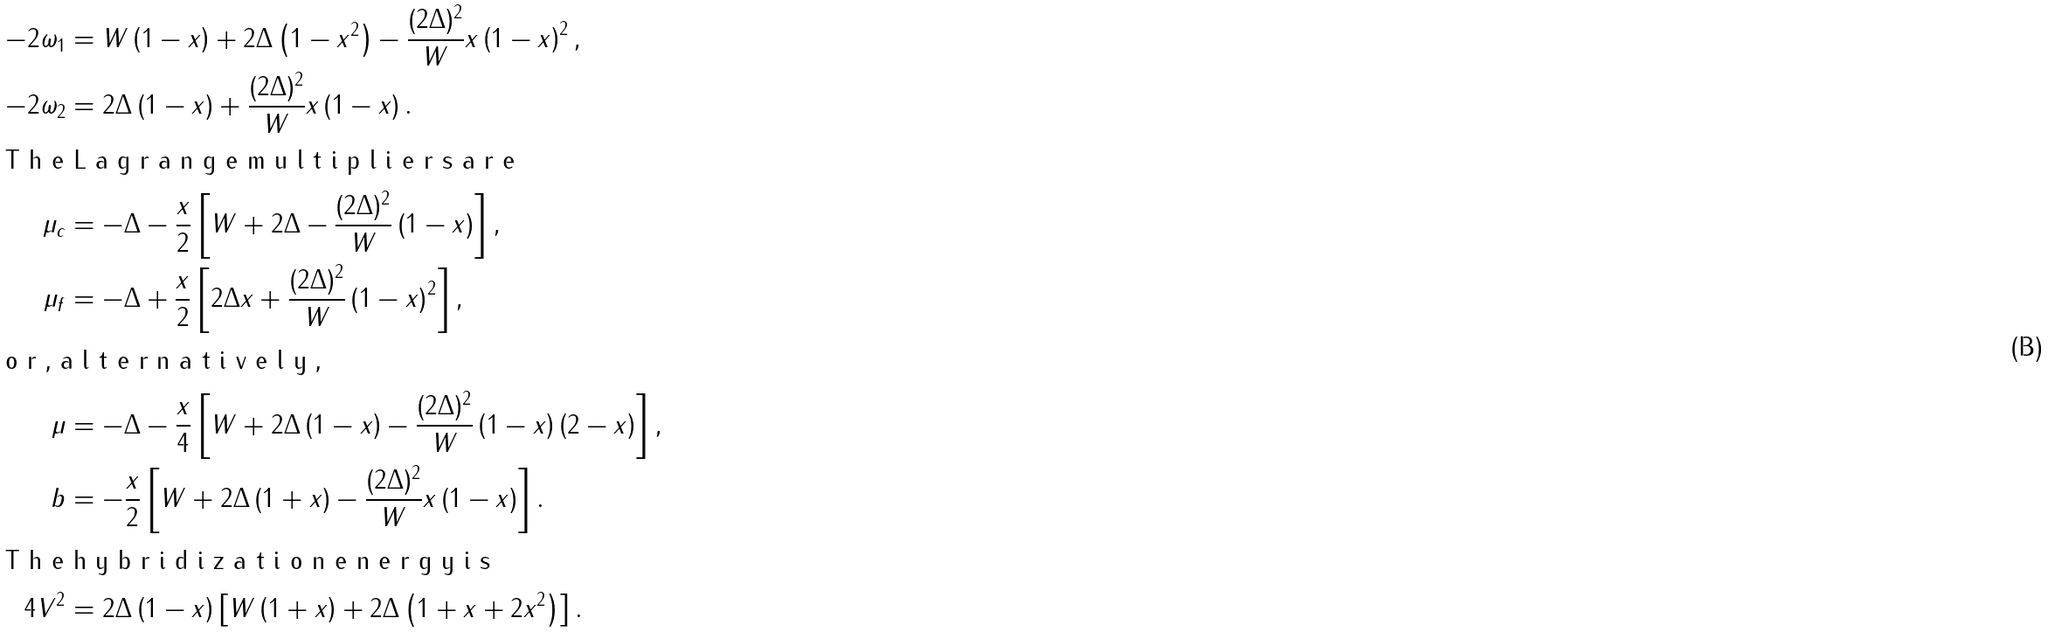<formula> <loc_0><loc_0><loc_500><loc_500>- 2 \omega _ { 1 } & = W \left ( 1 - x \right ) + 2 \Delta \left ( 1 - x ^ { 2 } \right ) - \frac { ( 2 \Delta ) ^ { 2 } } { W } x \left ( 1 - x \right ) ^ { 2 } , \\ - 2 \omega _ { 2 } & = 2 \Delta \left ( 1 - x \right ) + \frac { ( 2 \Delta ) ^ { 2 } } { W } x \left ( 1 - x \right ) . \intertext { T h e L a g r a n g e m u l t i p l i e r s a r e } \mu _ { c } & = - \Delta - \frac { x } { 2 } \left [ W + 2 \Delta - \frac { ( 2 \Delta ) ^ { 2 } } { W } \left ( 1 - x \right ) \right ] , \\ \mu _ { f } & = - \Delta + \frac { x } { 2 } \left [ 2 \Delta x + \frac { ( 2 \Delta ) ^ { 2 } } { W } \left ( 1 - x \right ) ^ { 2 } \right ] , \intertext { o r , a l t e r n a t i v e l y , } \mu & = - \Delta - \frac { x } { 4 } \left [ W + 2 \Delta \left ( 1 - x \right ) - \frac { ( 2 \Delta ) ^ { 2 } } { W } \left ( 1 - x \right ) \left ( 2 - x \right ) \right ] , \\ b & = - \frac { x } { 2 } \left [ W + 2 \Delta \left ( 1 + x \right ) - \frac { ( 2 \Delta ) ^ { 2 } } { W } x \left ( 1 - x \right ) \right ] . \intertext { T h e h y b r i d i z a t i o n e n e r g y i s } 4 V ^ { 2 } & = 2 \Delta \left ( 1 - x \right ) \left [ W \left ( 1 + x \right ) + 2 \Delta \left ( 1 + x + 2 x ^ { 2 } \right ) \right ] .</formula> 